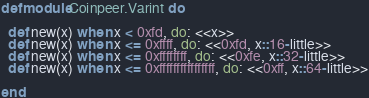Convert code to text. <code><loc_0><loc_0><loc_500><loc_500><_Elixir_>defmodule Coinpeer.Varint do

  def new(x) when x < 0xfd, do: <<x>>
  def new(x) when x <= 0xffff, do: <<0xfd, x::16-little>>
  def new(x) when x <= 0xffffffff, do: <<0xfe, x::32-little>>
  def new(x) when x <= 0xffffffffffffffff, do: <<0xff, x::64-little>>

end</code> 